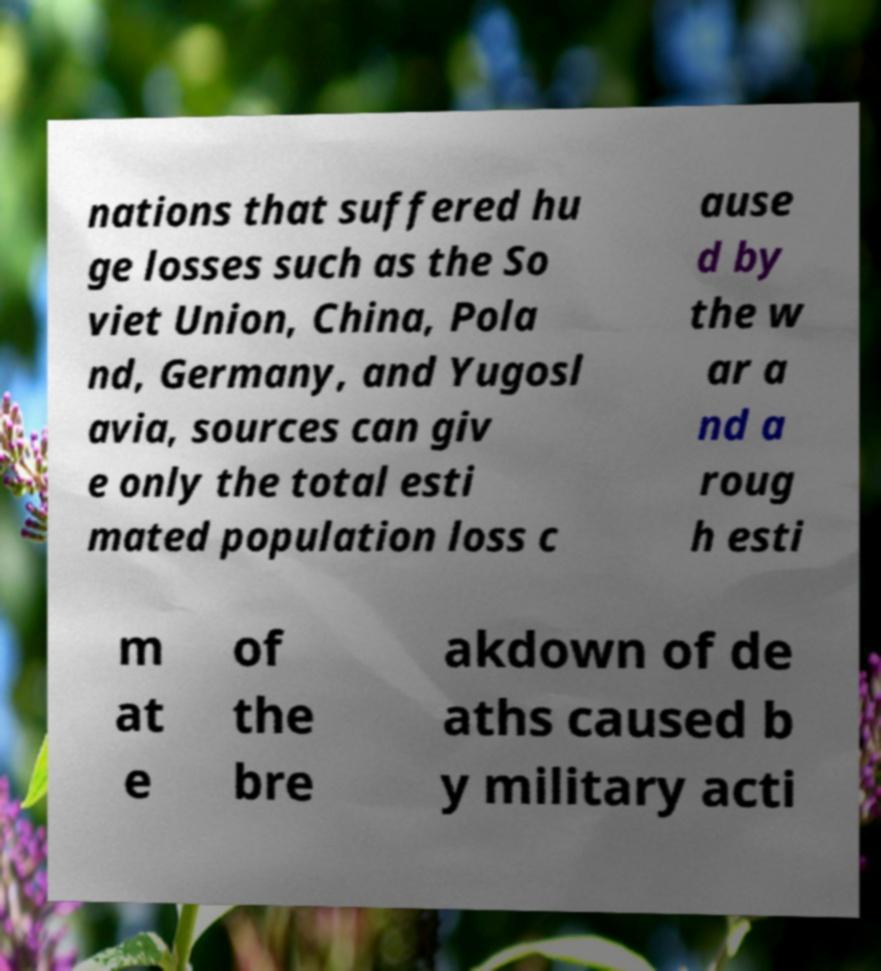Can you read and provide the text displayed in the image?This photo seems to have some interesting text. Can you extract and type it out for me? nations that suffered hu ge losses such as the So viet Union, China, Pola nd, Germany, and Yugosl avia, sources can giv e only the total esti mated population loss c ause d by the w ar a nd a roug h esti m at e of the bre akdown of de aths caused b y military acti 